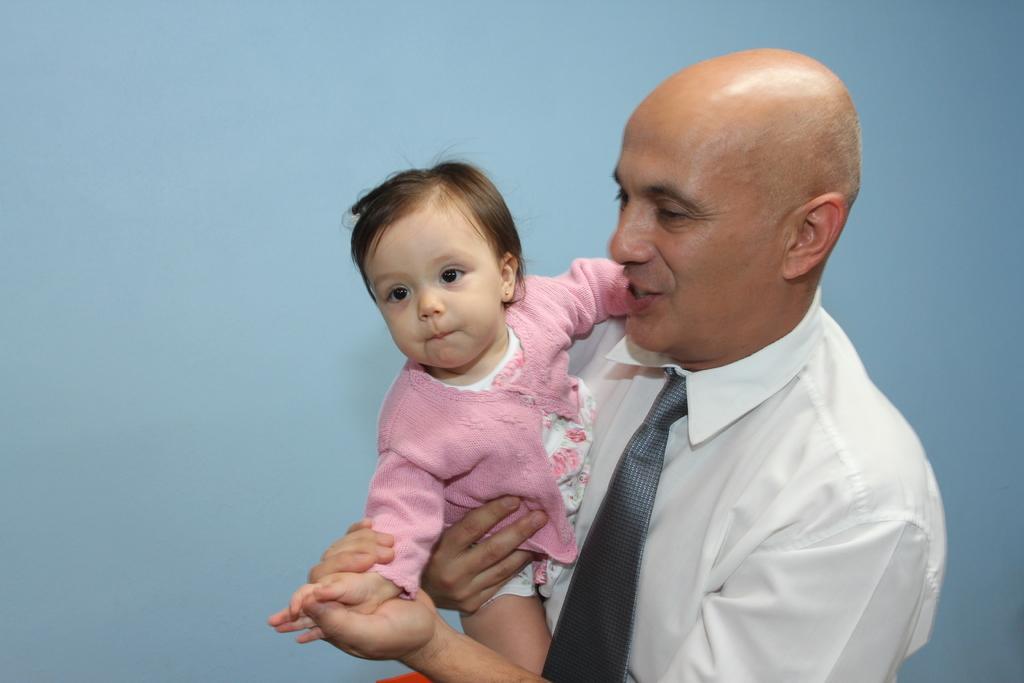Describe this image in one or two sentences. In this image in the front there is a person holding a baby in his arms and smiling. 